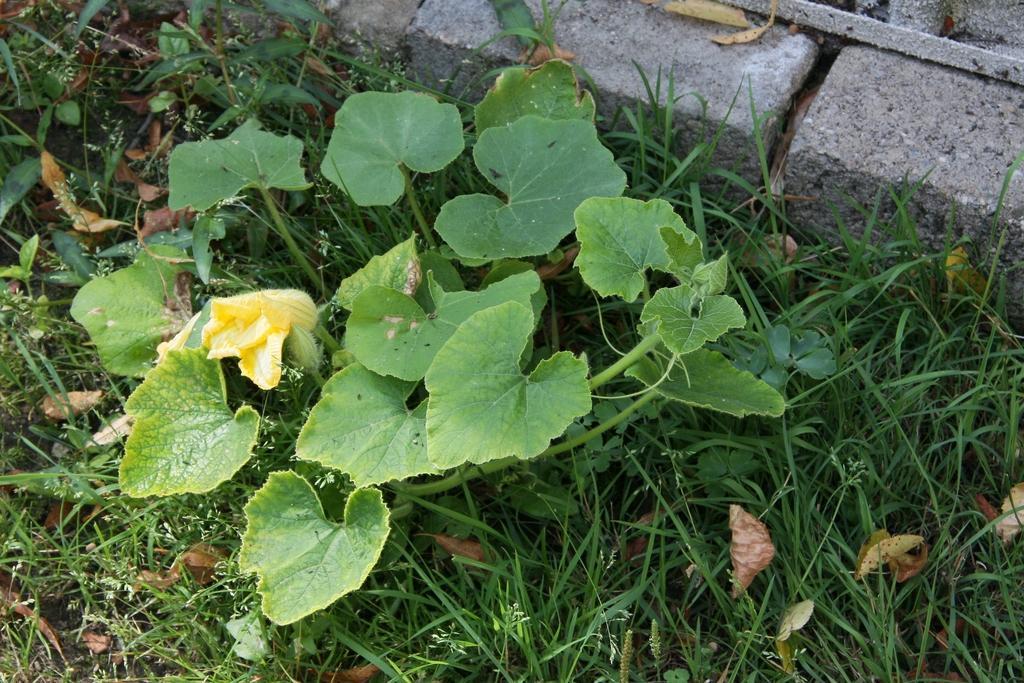Can you describe this image briefly? In this picture we can observe some plants on the ground. We can observe some grass here. There are some cement stones. 